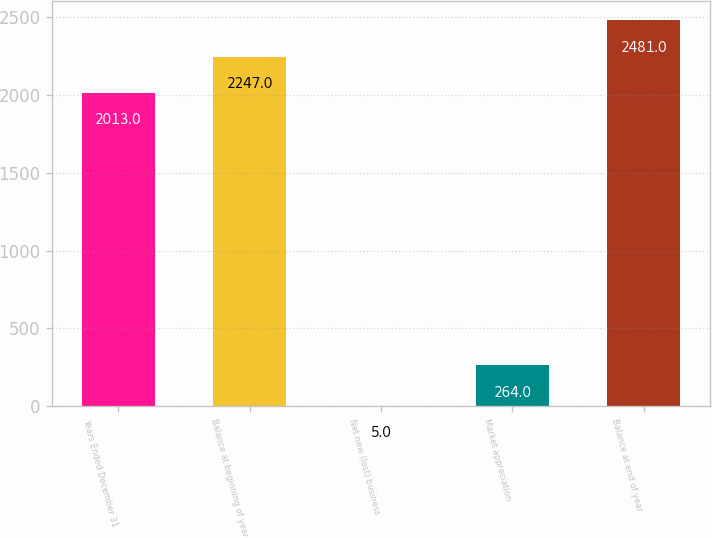Convert chart. <chart><loc_0><loc_0><loc_500><loc_500><bar_chart><fcel>Years Ended December 31<fcel>Balance at beginning of year<fcel>Net new (lost) business<fcel>Market appreciation<fcel>Balance at end of year<nl><fcel>2013<fcel>2247<fcel>5<fcel>264<fcel>2481<nl></chart> 